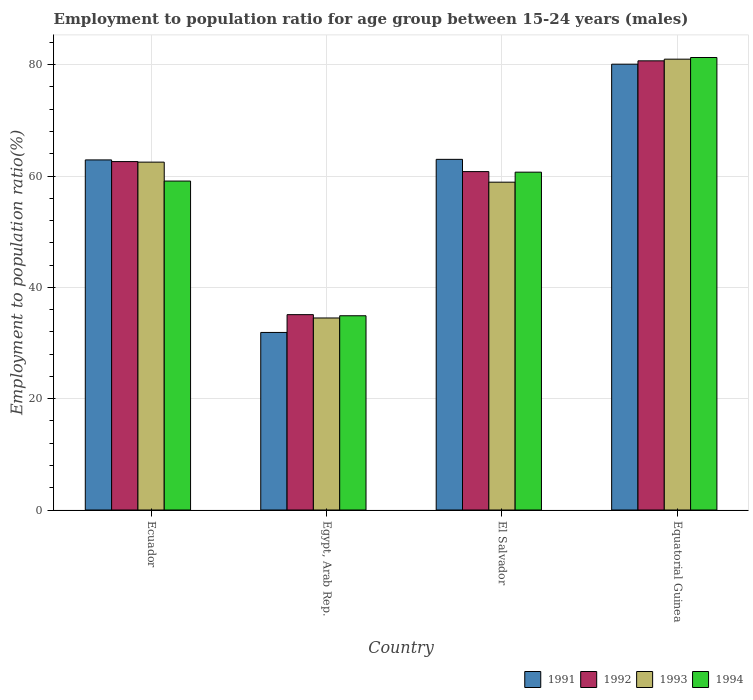How many groups of bars are there?
Your response must be concise. 4. Are the number of bars per tick equal to the number of legend labels?
Offer a terse response. Yes. How many bars are there on the 3rd tick from the left?
Provide a succinct answer. 4. How many bars are there on the 4th tick from the right?
Offer a very short reply. 4. What is the label of the 1st group of bars from the left?
Offer a terse response. Ecuador. What is the employment to population ratio in 1992 in El Salvador?
Your answer should be very brief. 60.8. Across all countries, what is the maximum employment to population ratio in 1993?
Make the answer very short. 81. Across all countries, what is the minimum employment to population ratio in 1994?
Your response must be concise. 34.9. In which country was the employment to population ratio in 1994 maximum?
Provide a succinct answer. Equatorial Guinea. In which country was the employment to population ratio in 1992 minimum?
Provide a short and direct response. Egypt, Arab Rep. What is the total employment to population ratio in 1993 in the graph?
Offer a terse response. 236.9. What is the difference between the employment to population ratio in 1992 in Egypt, Arab Rep. and that in Equatorial Guinea?
Your answer should be compact. -45.6. What is the average employment to population ratio in 1991 per country?
Give a very brief answer. 59.47. What is the ratio of the employment to population ratio in 1991 in Egypt, Arab Rep. to that in Equatorial Guinea?
Your answer should be compact. 0.4. Is the employment to population ratio in 1991 in Egypt, Arab Rep. less than that in Equatorial Guinea?
Offer a terse response. Yes. Is the difference between the employment to population ratio in 1994 in Egypt, Arab Rep. and El Salvador greater than the difference between the employment to population ratio in 1992 in Egypt, Arab Rep. and El Salvador?
Your answer should be compact. No. What is the difference between the highest and the second highest employment to population ratio in 1993?
Offer a very short reply. 22.1. What is the difference between the highest and the lowest employment to population ratio in 1991?
Offer a terse response. 48.2. In how many countries, is the employment to population ratio in 1991 greater than the average employment to population ratio in 1991 taken over all countries?
Provide a succinct answer. 3. Is it the case that in every country, the sum of the employment to population ratio in 1994 and employment to population ratio in 1992 is greater than the sum of employment to population ratio in 1991 and employment to population ratio in 1993?
Provide a succinct answer. No. Is it the case that in every country, the sum of the employment to population ratio in 1992 and employment to population ratio in 1994 is greater than the employment to population ratio in 1993?
Provide a short and direct response. Yes. Are all the bars in the graph horizontal?
Provide a succinct answer. No. Does the graph contain grids?
Provide a short and direct response. Yes. How many legend labels are there?
Make the answer very short. 4. How are the legend labels stacked?
Provide a short and direct response. Horizontal. What is the title of the graph?
Give a very brief answer. Employment to population ratio for age group between 15-24 years (males). What is the label or title of the Y-axis?
Make the answer very short. Employment to population ratio(%). What is the Employment to population ratio(%) of 1991 in Ecuador?
Ensure brevity in your answer.  62.9. What is the Employment to population ratio(%) of 1992 in Ecuador?
Keep it short and to the point. 62.6. What is the Employment to population ratio(%) in 1993 in Ecuador?
Your answer should be very brief. 62.5. What is the Employment to population ratio(%) in 1994 in Ecuador?
Offer a very short reply. 59.1. What is the Employment to population ratio(%) in 1991 in Egypt, Arab Rep.?
Your answer should be compact. 31.9. What is the Employment to population ratio(%) in 1992 in Egypt, Arab Rep.?
Provide a succinct answer. 35.1. What is the Employment to population ratio(%) in 1993 in Egypt, Arab Rep.?
Keep it short and to the point. 34.5. What is the Employment to population ratio(%) in 1994 in Egypt, Arab Rep.?
Offer a very short reply. 34.9. What is the Employment to population ratio(%) in 1991 in El Salvador?
Ensure brevity in your answer.  63. What is the Employment to population ratio(%) of 1992 in El Salvador?
Offer a very short reply. 60.8. What is the Employment to population ratio(%) in 1993 in El Salvador?
Keep it short and to the point. 58.9. What is the Employment to population ratio(%) in 1994 in El Salvador?
Your response must be concise. 60.7. What is the Employment to population ratio(%) in 1991 in Equatorial Guinea?
Your answer should be very brief. 80.1. What is the Employment to population ratio(%) of 1992 in Equatorial Guinea?
Keep it short and to the point. 80.7. What is the Employment to population ratio(%) of 1994 in Equatorial Guinea?
Your answer should be very brief. 81.3. Across all countries, what is the maximum Employment to population ratio(%) of 1991?
Give a very brief answer. 80.1. Across all countries, what is the maximum Employment to population ratio(%) in 1992?
Your answer should be compact. 80.7. Across all countries, what is the maximum Employment to population ratio(%) in 1993?
Ensure brevity in your answer.  81. Across all countries, what is the maximum Employment to population ratio(%) in 1994?
Offer a terse response. 81.3. Across all countries, what is the minimum Employment to population ratio(%) in 1991?
Provide a succinct answer. 31.9. Across all countries, what is the minimum Employment to population ratio(%) in 1992?
Ensure brevity in your answer.  35.1. Across all countries, what is the minimum Employment to population ratio(%) in 1993?
Your answer should be very brief. 34.5. Across all countries, what is the minimum Employment to population ratio(%) in 1994?
Give a very brief answer. 34.9. What is the total Employment to population ratio(%) in 1991 in the graph?
Offer a very short reply. 237.9. What is the total Employment to population ratio(%) in 1992 in the graph?
Ensure brevity in your answer.  239.2. What is the total Employment to population ratio(%) of 1993 in the graph?
Provide a succinct answer. 236.9. What is the total Employment to population ratio(%) in 1994 in the graph?
Your answer should be compact. 236. What is the difference between the Employment to population ratio(%) of 1993 in Ecuador and that in Egypt, Arab Rep.?
Your response must be concise. 28. What is the difference between the Employment to population ratio(%) in 1994 in Ecuador and that in Egypt, Arab Rep.?
Provide a short and direct response. 24.2. What is the difference between the Employment to population ratio(%) in 1991 in Ecuador and that in El Salvador?
Give a very brief answer. -0.1. What is the difference between the Employment to population ratio(%) of 1994 in Ecuador and that in El Salvador?
Provide a short and direct response. -1.6. What is the difference between the Employment to population ratio(%) in 1991 in Ecuador and that in Equatorial Guinea?
Offer a terse response. -17.2. What is the difference between the Employment to population ratio(%) in 1992 in Ecuador and that in Equatorial Guinea?
Provide a succinct answer. -18.1. What is the difference between the Employment to population ratio(%) in 1993 in Ecuador and that in Equatorial Guinea?
Your answer should be compact. -18.5. What is the difference between the Employment to population ratio(%) in 1994 in Ecuador and that in Equatorial Guinea?
Give a very brief answer. -22.2. What is the difference between the Employment to population ratio(%) in 1991 in Egypt, Arab Rep. and that in El Salvador?
Provide a succinct answer. -31.1. What is the difference between the Employment to population ratio(%) of 1992 in Egypt, Arab Rep. and that in El Salvador?
Your response must be concise. -25.7. What is the difference between the Employment to population ratio(%) of 1993 in Egypt, Arab Rep. and that in El Salvador?
Give a very brief answer. -24.4. What is the difference between the Employment to population ratio(%) in 1994 in Egypt, Arab Rep. and that in El Salvador?
Offer a very short reply. -25.8. What is the difference between the Employment to population ratio(%) of 1991 in Egypt, Arab Rep. and that in Equatorial Guinea?
Make the answer very short. -48.2. What is the difference between the Employment to population ratio(%) in 1992 in Egypt, Arab Rep. and that in Equatorial Guinea?
Provide a succinct answer. -45.6. What is the difference between the Employment to population ratio(%) of 1993 in Egypt, Arab Rep. and that in Equatorial Guinea?
Make the answer very short. -46.5. What is the difference between the Employment to population ratio(%) in 1994 in Egypt, Arab Rep. and that in Equatorial Guinea?
Your response must be concise. -46.4. What is the difference between the Employment to population ratio(%) of 1991 in El Salvador and that in Equatorial Guinea?
Provide a short and direct response. -17.1. What is the difference between the Employment to population ratio(%) of 1992 in El Salvador and that in Equatorial Guinea?
Provide a short and direct response. -19.9. What is the difference between the Employment to population ratio(%) of 1993 in El Salvador and that in Equatorial Guinea?
Your answer should be compact. -22.1. What is the difference between the Employment to population ratio(%) of 1994 in El Salvador and that in Equatorial Guinea?
Offer a very short reply. -20.6. What is the difference between the Employment to population ratio(%) in 1991 in Ecuador and the Employment to population ratio(%) in 1992 in Egypt, Arab Rep.?
Offer a terse response. 27.8. What is the difference between the Employment to population ratio(%) of 1991 in Ecuador and the Employment to population ratio(%) of 1993 in Egypt, Arab Rep.?
Offer a very short reply. 28.4. What is the difference between the Employment to population ratio(%) in 1992 in Ecuador and the Employment to population ratio(%) in 1993 in Egypt, Arab Rep.?
Provide a short and direct response. 28.1. What is the difference between the Employment to population ratio(%) in 1992 in Ecuador and the Employment to population ratio(%) in 1994 in Egypt, Arab Rep.?
Give a very brief answer. 27.7. What is the difference between the Employment to population ratio(%) in 1993 in Ecuador and the Employment to population ratio(%) in 1994 in Egypt, Arab Rep.?
Your response must be concise. 27.6. What is the difference between the Employment to population ratio(%) in 1991 in Ecuador and the Employment to population ratio(%) in 1992 in El Salvador?
Your answer should be compact. 2.1. What is the difference between the Employment to population ratio(%) of 1993 in Ecuador and the Employment to population ratio(%) of 1994 in El Salvador?
Your answer should be compact. 1.8. What is the difference between the Employment to population ratio(%) in 1991 in Ecuador and the Employment to population ratio(%) in 1992 in Equatorial Guinea?
Offer a terse response. -17.8. What is the difference between the Employment to population ratio(%) in 1991 in Ecuador and the Employment to population ratio(%) in 1993 in Equatorial Guinea?
Provide a succinct answer. -18.1. What is the difference between the Employment to population ratio(%) of 1991 in Ecuador and the Employment to population ratio(%) of 1994 in Equatorial Guinea?
Ensure brevity in your answer.  -18.4. What is the difference between the Employment to population ratio(%) in 1992 in Ecuador and the Employment to population ratio(%) in 1993 in Equatorial Guinea?
Provide a short and direct response. -18.4. What is the difference between the Employment to population ratio(%) in 1992 in Ecuador and the Employment to population ratio(%) in 1994 in Equatorial Guinea?
Your answer should be very brief. -18.7. What is the difference between the Employment to population ratio(%) in 1993 in Ecuador and the Employment to population ratio(%) in 1994 in Equatorial Guinea?
Make the answer very short. -18.8. What is the difference between the Employment to population ratio(%) in 1991 in Egypt, Arab Rep. and the Employment to population ratio(%) in 1992 in El Salvador?
Offer a very short reply. -28.9. What is the difference between the Employment to population ratio(%) in 1991 in Egypt, Arab Rep. and the Employment to population ratio(%) in 1994 in El Salvador?
Your answer should be very brief. -28.8. What is the difference between the Employment to population ratio(%) in 1992 in Egypt, Arab Rep. and the Employment to population ratio(%) in 1993 in El Salvador?
Provide a short and direct response. -23.8. What is the difference between the Employment to population ratio(%) in 1992 in Egypt, Arab Rep. and the Employment to population ratio(%) in 1994 in El Salvador?
Provide a succinct answer. -25.6. What is the difference between the Employment to population ratio(%) of 1993 in Egypt, Arab Rep. and the Employment to population ratio(%) of 1994 in El Salvador?
Make the answer very short. -26.2. What is the difference between the Employment to population ratio(%) in 1991 in Egypt, Arab Rep. and the Employment to population ratio(%) in 1992 in Equatorial Guinea?
Provide a short and direct response. -48.8. What is the difference between the Employment to population ratio(%) of 1991 in Egypt, Arab Rep. and the Employment to population ratio(%) of 1993 in Equatorial Guinea?
Your answer should be compact. -49.1. What is the difference between the Employment to population ratio(%) of 1991 in Egypt, Arab Rep. and the Employment to population ratio(%) of 1994 in Equatorial Guinea?
Make the answer very short. -49.4. What is the difference between the Employment to population ratio(%) in 1992 in Egypt, Arab Rep. and the Employment to population ratio(%) in 1993 in Equatorial Guinea?
Give a very brief answer. -45.9. What is the difference between the Employment to population ratio(%) of 1992 in Egypt, Arab Rep. and the Employment to population ratio(%) of 1994 in Equatorial Guinea?
Keep it short and to the point. -46.2. What is the difference between the Employment to population ratio(%) in 1993 in Egypt, Arab Rep. and the Employment to population ratio(%) in 1994 in Equatorial Guinea?
Your response must be concise. -46.8. What is the difference between the Employment to population ratio(%) in 1991 in El Salvador and the Employment to population ratio(%) in 1992 in Equatorial Guinea?
Your answer should be very brief. -17.7. What is the difference between the Employment to population ratio(%) in 1991 in El Salvador and the Employment to population ratio(%) in 1993 in Equatorial Guinea?
Ensure brevity in your answer.  -18. What is the difference between the Employment to population ratio(%) in 1991 in El Salvador and the Employment to population ratio(%) in 1994 in Equatorial Guinea?
Offer a terse response. -18.3. What is the difference between the Employment to population ratio(%) in 1992 in El Salvador and the Employment to population ratio(%) in 1993 in Equatorial Guinea?
Offer a terse response. -20.2. What is the difference between the Employment to population ratio(%) of 1992 in El Salvador and the Employment to population ratio(%) of 1994 in Equatorial Guinea?
Provide a short and direct response. -20.5. What is the difference between the Employment to population ratio(%) of 1993 in El Salvador and the Employment to population ratio(%) of 1994 in Equatorial Guinea?
Offer a very short reply. -22.4. What is the average Employment to population ratio(%) of 1991 per country?
Offer a terse response. 59.48. What is the average Employment to population ratio(%) in 1992 per country?
Give a very brief answer. 59.8. What is the average Employment to population ratio(%) in 1993 per country?
Your response must be concise. 59.23. What is the average Employment to population ratio(%) of 1994 per country?
Provide a short and direct response. 59. What is the difference between the Employment to population ratio(%) of 1991 and Employment to population ratio(%) of 1992 in Ecuador?
Provide a succinct answer. 0.3. What is the difference between the Employment to population ratio(%) of 1992 and Employment to population ratio(%) of 1993 in Ecuador?
Keep it short and to the point. 0.1. What is the difference between the Employment to population ratio(%) of 1993 and Employment to population ratio(%) of 1994 in Egypt, Arab Rep.?
Give a very brief answer. -0.4. What is the difference between the Employment to population ratio(%) of 1991 and Employment to population ratio(%) of 1993 in El Salvador?
Provide a short and direct response. 4.1. What is the difference between the Employment to population ratio(%) in 1991 and Employment to population ratio(%) in 1994 in El Salvador?
Offer a very short reply. 2.3. What is the difference between the Employment to population ratio(%) of 1992 and Employment to population ratio(%) of 1993 in El Salvador?
Provide a short and direct response. 1.9. What is the difference between the Employment to population ratio(%) in 1993 and Employment to population ratio(%) in 1994 in El Salvador?
Your answer should be very brief. -1.8. What is the difference between the Employment to population ratio(%) in 1991 and Employment to population ratio(%) in 1994 in Equatorial Guinea?
Give a very brief answer. -1.2. What is the difference between the Employment to population ratio(%) of 1992 and Employment to population ratio(%) of 1993 in Equatorial Guinea?
Ensure brevity in your answer.  -0.3. What is the ratio of the Employment to population ratio(%) in 1991 in Ecuador to that in Egypt, Arab Rep.?
Your response must be concise. 1.97. What is the ratio of the Employment to population ratio(%) in 1992 in Ecuador to that in Egypt, Arab Rep.?
Provide a short and direct response. 1.78. What is the ratio of the Employment to population ratio(%) in 1993 in Ecuador to that in Egypt, Arab Rep.?
Offer a terse response. 1.81. What is the ratio of the Employment to population ratio(%) in 1994 in Ecuador to that in Egypt, Arab Rep.?
Offer a very short reply. 1.69. What is the ratio of the Employment to population ratio(%) in 1992 in Ecuador to that in El Salvador?
Offer a terse response. 1.03. What is the ratio of the Employment to population ratio(%) in 1993 in Ecuador to that in El Salvador?
Offer a very short reply. 1.06. What is the ratio of the Employment to population ratio(%) in 1994 in Ecuador to that in El Salvador?
Make the answer very short. 0.97. What is the ratio of the Employment to population ratio(%) of 1991 in Ecuador to that in Equatorial Guinea?
Give a very brief answer. 0.79. What is the ratio of the Employment to population ratio(%) in 1992 in Ecuador to that in Equatorial Guinea?
Offer a terse response. 0.78. What is the ratio of the Employment to population ratio(%) in 1993 in Ecuador to that in Equatorial Guinea?
Offer a terse response. 0.77. What is the ratio of the Employment to population ratio(%) in 1994 in Ecuador to that in Equatorial Guinea?
Make the answer very short. 0.73. What is the ratio of the Employment to population ratio(%) of 1991 in Egypt, Arab Rep. to that in El Salvador?
Provide a succinct answer. 0.51. What is the ratio of the Employment to population ratio(%) of 1992 in Egypt, Arab Rep. to that in El Salvador?
Provide a short and direct response. 0.58. What is the ratio of the Employment to population ratio(%) in 1993 in Egypt, Arab Rep. to that in El Salvador?
Offer a very short reply. 0.59. What is the ratio of the Employment to population ratio(%) in 1994 in Egypt, Arab Rep. to that in El Salvador?
Your response must be concise. 0.57. What is the ratio of the Employment to population ratio(%) in 1991 in Egypt, Arab Rep. to that in Equatorial Guinea?
Provide a succinct answer. 0.4. What is the ratio of the Employment to population ratio(%) of 1992 in Egypt, Arab Rep. to that in Equatorial Guinea?
Ensure brevity in your answer.  0.43. What is the ratio of the Employment to population ratio(%) of 1993 in Egypt, Arab Rep. to that in Equatorial Guinea?
Your answer should be compact. 0.43. What is the ratio of the Employment to population ratio(%) in 1994 in Egypt, Arab Rep. to that in Equatorial Guinea?
Offer a terse response. 0.43. What is the ratio of the Employment to population ratio(%) of 1991 in El Salvador to that in Equatorial Guinea?
Give a very brief answer. 0.79. What is the ratio of the Employment to population ratio(%) of 1992 in El Salvador to that in Equatorial Guinea?
Offer a terse response. 0.75. What is the ratio of the Employment to population ratio(%) in 1993 in El Salvador to that in Equatorial Guinea?
Make the answer very short. 0.73. What is the ratio of the Employment to population ratio(%) of 1994 in El Salvador to that in Equatorial Guinea?
Offer a very short reply. 0.75. What is the difference between the highest and the second highest Employment to population ratio(%) of 1994?
Offer a terse response. 20.6. What is the difference between the highest and the lowest Employment to population ratio(%) of 1991?
Give a very brief answer. 48.2. What is the difference between the highest and the lowest Employment to population ratio(%) of 1992?
Offer a very short reply. 45.6. What is the difference between the highest and the lowest Employment to population ratio(%) in 1993?
Provide a succinct answer. 46.5. What is the difference between the highest and the lowest Employment to population ratio(%) of 1994?
Offer a very short reply. 46.4. 